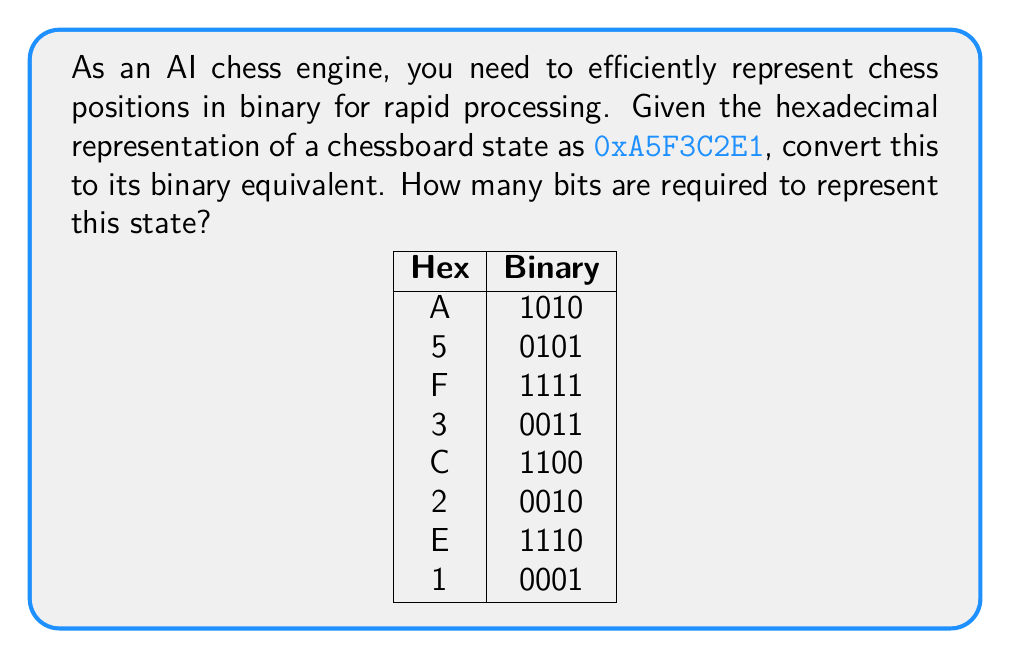Teach me how to tackle this problem. Let's approach this step-by-step:

1) First, we need to convert the hexadecimal number to binary. Each hexadecimal digit represents 4 bits in binary.

2) Let's convert each hexadecimal digit to its 4-bit binary equivalent:

   A = 1010
   5 = 0101
   F = 1111
   3 = 0011
   C = 1100
   2 = 0010
   E = 1110
   1 = 0001

3) Now, we concatenate these binary numbers in the same order:

   0xA5F3C2E1 = 1010 0101 1111 0011 1100 0010 1110 0001

4) To count the number of bits, we can multiply the number of hexadecimal digits by 4:

   Number of bits = Number of hexadecimal digits × 4
                  = 8 × 4 = 32

Therefore, 32 bits are required to represent this state.

This conversion allows for efficient data representation and processing in the AI chess engine's algorithms and neural networks.
Answer: 32 bits 